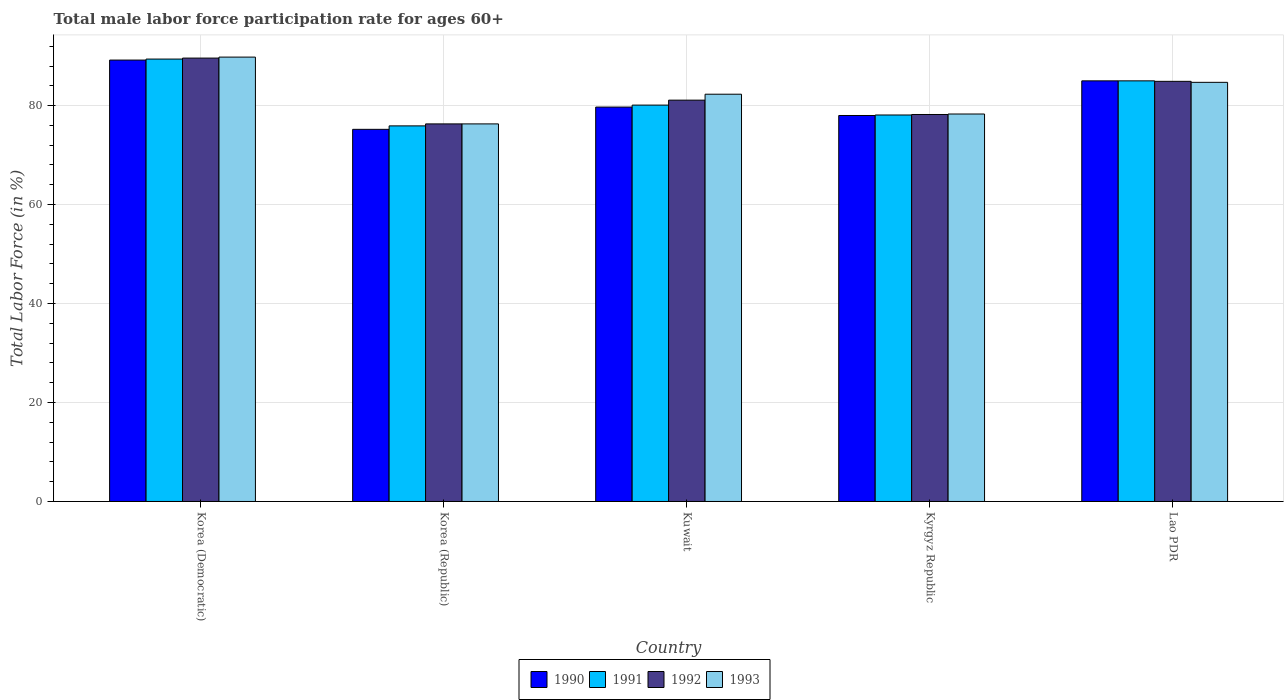How many different coloured bars are there?
Offer a very short reply. 4. How many bars are there on the 1st tick from the left?
Offer a very short reply. 4. How many bars are there on the 4th tick from the right?
Your answer should be compact. 4. What is the label of the 4th group of bars from the left?
Offer a terse response. Kyrgyz Republic. In how many cases, is the number of bars for a given country not equal to the number of legend labels?
Your answer should be compact. 0. What is the male labor force participation rate in 1992 in Lao PDR?
Keep it short and to the point. 84.9. Across all countries, what is the maximum male labor force participation rate in 1990?
Offer a terse response. 89.2. Across all countries, what is the minimum male labor force participation rate in 1992?
Offer a very short reply. 76.3. In which country was the male labor force participation rate in 1991 maximum?
Your answer should be compact. Korea (Democratic). What is the total male labor force participation rate in 1993 in the graph?
Make the answer very short. 411.4. What is the difference between the male labor force participation rate in 1991 in Kuwait and that in Lao PDR?
Your answer should be very brief. -4.9. What is the difference between the male labor force participation rate in 1993 in Korea (Democratic) and the male labor force participation rate in 1992 in Kyrgyz Republic?
Your answer should be compact. 11.6. What is the average male labor force participation rate in 1993 per country?
Provide a succinct answer. 82.28. What is the difference between the male labor force participation rate of/in 1990 and male labor force participation rate of/in 1993 in Korea (Republic)?
Provide a short and direct response. -1.1. What is the ratio of the male labor force participation rate in 1993 in Korea (Democratic) to that in Lao PDR?
Make the answer very short. 1.06. Is the male labor force participation rate in 1991 in Korea (Republic) less than that in Kuwait?
Your response must be concise. Yes. Is the difference between the male labor force participation rate in 1990 in Korea (Republic) and Kuwait greater than the difference between the male labor force participation rate in 1993 in Korea (Republic) and Kuwait?
Keep it short and to the point. Yes. What is the difference between the highest and the second highest male labor force participation rate in 1990?
Your response must be concise. 4.2. Is it the case that in every country, the sum of the male labor force participation rate in 1993 and male labor force participation rate in 1991 is greater than the sum of male labor force participation rate in 1992 and male labor force participation rate in 1990?
Your response must be concise. No. What does the 2nd bar from the left in Korea (Democratic) represents?
Keep it short and to the point. 1991. What does the 3rd bar from the right in Kuwait represents?
Provide a succinct answer. 1991. Is it the case that in every country, the sum of the male labor force participation rate in 1993 and male labor force participation rate in 1991 is greater than the male labor force participation rate in 1990?
Offer a very short reply. Yes. Are the values on the major ticks of Y-axis written in scientific E-notation?
Offer a terse response. No. Does the graph contain grids?
Provide a short and direct response. Yes. Where does the legend appear in the graph?
Provide a short and direct response. Bottom center. How many legend labels are there?
Keep it short and to the point. 4. How are the legend labels stacked?
Ensure brevity in your answer.  Horizontal. What is the title of the graph?
Your answer should be very brief. Total male labor force participation rate for ages 60+. Does "1961" appear as one of the legend labels in the graph?
Provide a succinct answer. No. What is the label or title of the Y-axis?
Your response must be concise. Total Labor Force (in %). What is the Total Labor Force (in %) of 1990 in Korea (Democratic)?
Keep it short and to the point. 89.2. What is the Total Labor Force (in %) of 1991 in Korea (Democratic)?
Your answer should be compact. 89.4. What is the Total Labor Force (in %) in 1992 in Korea (Democratic)?
Your answer should be compact. 89.6. What is the Total Labor Force (in %) of 1993 in Korea (Democratic)?
Ensure brevity in your answer.  89.8. What is the Total Labor Force (in %) of 1990 in Korea (Republic)?
Your response must be concise. 75.2. What is the Total Labor Force (in %) in 1991 in Korea (Republic)?
Make the answer very short. 75.9. What is the Total Labor Force (in %) in 1992 in Korea (Republic)?
Provide a short and direct response. 76.3. What is the Total Labor Force (in %) of 1993 in Korea (Republic)?
Your answer should be compact. 76.3. What is the Total Labor Force (in %) in 1990 in Kuwait?
Provide a short and direct response. 79.7. What is the Total Labor Force (in %) in 1991 in Kuwait?
Give a very brief answer. 80.1. What is the Total Labor Force (in %) in 1992 in Kuwait?
Offer a very short reply. 81.1. What is the Total Labor Force (in %) of 1993 in Kuwait?
Offer a very short reply. 82.3. What is the Total Labor Force (in %) of 1991 in Kyrgyz Republic?
Your answer should be compact. 78.1. What is the Total Labor Force (in %) in 1992 in Kyrgyz Republic?
Make the answer very short. 78.2. What is the Total Labor Force (in %) in 1993 in Kyrgyz Republic?
Offer a very short reply. 78.3. What is the Total Labor Force (in %) of 1992 in Lao PDR?
Your answer should be very brief. 84.9. What is the Total Labor Force (in %) of 1993 in Lao PDR?
Offer a very short reply. 84.7. Across all countries, what is the maximum Total Labor Force (in %) in 1990?
Provide a short and direct response. 89.2. Across all countries, what is the maximum Total Labor Force (in %) of 1991?
Provide a succinct answer. 89.4. Across all countries, what is the maximum Total Labor Force (in %) of 1992?
Your answer should be compact. 89.6. Across all countries, what is the maximum Total Labor Force (in %) of 1993?
Give a very brief answer. 89.8. Across all countries, what is the minimum Total Labor Force (in %) in 1990?
Your response must be concise. 75.2. Across all countries, what is the minimum Total Labor Force (in %) of 1991?
Make the answer very short. 75.9. Across all countries, what is the minimum Total Labor Force (in %) of 1992?
Make the answer very short. 76.3. Across all countries, what is the minimum Total Labor Force (in %) of 1993?
Give a very brief answer. 76.3. What is the total Total Labor Force (in %) of 1990 in the graph?
Offer a terse response. 407.1. What is the total Total Labor Force (in %) in 1991 in the graph?
Give a very brief answer. 408.5. What is the total Total Labor Force (in %) of 1992 in the graph?
Your answer should be very brief. 410.1. What is the total Total Labor Force (in %) in 1993 in the graph?
Give a very brief answer. 411.4. What is the difference between the Total Labor Force (in %) of 1990 in Korea (Democratic) and that in Korea (Republic)?
Provide a succinct answer. 14. What is the difference between the Total Labor Force (in %) of 1992 in Korea (Democratic) and that in Korea (Republic)?
Give a very brief answer. 13.3. What is the difference between the Total Labor Force (in %) of 1991 in Korea (Democratic) and that in Kuwait?
Provide a succinct answer. 9.3. What is the difference between the Total Labor Force (in %) in 1990 in Korea (Democratic) and that in Lao PDR?
Give a very brief answer. 4.2. What is the difference between the Total Labor Force (in %) in 1992 in Korea (Democratic) and that in Lao PDR?
Your response must be concise. 4.7. What is the difference between the Total Labor Force (in %) of 1993 in Korea (Democratic) and that in Lao PDR?
Provide a short and direct response. 5.1. What is the difference between the Total Labor Force (in %) of 1990 in Korea (Republic) and that in Kuwait?
Ensure brevity in your answer.  -4.5. What is the difference between the Total Labor Force (in %) of 1991 in Korea (Republic) and that in Kuwait?
Your answer should be very brief. -4.2. What is the difference between the Total Labor Force (in %) of 1992 in Korea (Republic) and that in Kuwait?
Provide a short and direct response. -4.8. What is the difference between the Total Labor Force (in %) of 1991 in Korea (Republic) and that in Kyrgyz Republic?
Offer a very short reply. -2.2. What is the difference between the Total Labor Force (in %) in 1993 in Korea (Republic) and that in Kyrgyz Republic?
Offer a terse response. -2. What is the difference between the Total Labor Force (in %) in 1992 in Korea (Republic) and that in Lao PDR?
Offer a terse response. -8.6. What is the difference between the Total Labor Force (in %) of 1990 in Kuwait and that in Kyrgyz Republic?
Provide a short and direct response. 1.7. What is the difference between the Total Labor Force (in %) in 1992 in Kuwait and that in Kyrgyz Republic?
Ensure brevity in your answer.  2.9. What is the difference between the Total Labor Force (in %) in 1990 in Kuwait and that in Lao PDR?
Your answer should be compact. -5.3. What is the difference between the Total Labor Force (in %) of 1991 in Kuwait and that in Lao PDR?
Give a very brief answer. -4.9. What is the difference between the Total Labor Force (in %) in 1992 in Kuwait and that in Lao PDR?
Provide a short and direct response. -3.8. What is the difference between the Total Labor Force (in %) of 1990 in Kyrgyz Republic and that in Lao PDR?
Offer a terse response. -7. What is the difference between the Total Labor Force (in %) of 1991 in Kyrgyz Republic and that in Lao PDR?
Your response must be concise. -6.9. What is the difference between the Total Labor Force (in %) of 1990 in Korea (Democratic) and the Total Labor Force (in %) of 1992 in Korea (Republic)?
Your response must be concise. 12.9. What is the difference between the Total Labor Force (in %) of 1990 in Korea (Democratic) and the Total Labor Force (in %) of 1993 in Korea (Republic)?
Your response must be concise. 12.9. What is the difference between the Total Labor Force (in %) of 1992 in Korea (Democratic) and the Total Labor Force (in %) of 1993 in Korea (Republic)?
Offer a very short reply. 13.3. What is the difference between the Total Labor Force (in %) in 1991 in Korea (Democratic) and the Total Labor Force (in %) in 1992 in Kuwait?
Make the answer very short. 8.3. What is the difference between the Total Labor Force (in %) of 1991 in Korea (Democratic) and the Total Labor Force (in %) of 1993 in Kuwait?
Provide a succinct answer. 7.1. What is the difference between the Total Labor Force (in %) of 1992 in Korea (Democratic) and the Total Labor Force (in %) of 1993 in Kuwait?
Your answer should be very brief. 7.3. What is the difference between the Total Labor Force (in %) of 1990 in Korea (Democratic) and the Total Labor Force (in %) of 1992 in Kyrgyz Republic?
Provide a short and direct response. 11. What is the difference between the Total Labor Force (in %) of 1990 in Korea (Democratic) and the Total Labor Force (in %) of 1993 in Kyrgyz Republic?
Provide a succinct answer. 10.9. What is the difference between the Total Labor Force (in %) of 1991 in Korea (Democratic) and the Total Labor Force (in %) of 1993 in Kyrgyz Republic?
Provide a short and direct response. 11.1. What is the difference between the Total Labor Force (in %) in 1990 in Korea (Democratic) and the Total Labor Force (in %) in 1992 in Lao PDR?
Give a very brief answer. 4.3. What is the difference between the Total Labor Force (in %) in 1990 in Korea (Democratic) and the Total Labor Force (in %) in 1993 in Lao PDR?
Your answer should be very brief. 4.5. What is the difference between the Total Labor Force (in %) in 1990 in Korea (Republic) and the Total Labor Force (in %) in 1991 in Kuwait?
Keep it short and to the point. -4.9. What is the difference between the Total Labor Force (in %) in 1990 in Korea (Republic) and the Total Labor Force (in %) in 1992 in Kuwait?
Offer a terse response. -5.9. What is the difference between the Total Labor Force (in %) of 1990 in Korea (Republic) and the Total Labor Force (in %) of 1993 in Kuwait?
Offer a terse response. -7.1. What is the difference between the Total Labor Force (in %) of 1991 in Korea (Republic) and the Total Labor Force (in %) of 1992 in Kuwait?
Your answer should be very brief. -5.2. What is the difference between the Total Labor Force (in %) in 1992 in Korea (Republic) and the Total Labor Force (in %) in 1993 in Kuwait?
Make the answer very short. -6. What is the difference between the Total Labor Force (in %) of 1990 in Korea (Republic) and the Total Labor Force (in %) of 1992 in Kyrgyz Republic?
Give a very brief answer. -3. What is the difference between the Total Labor Force (in %) in 1991 in Korea (Republic) and the Total Labor Force (in %) in 1993 in Kyrgyz Republic?
Ensure brevity in your answer.  -2.4. What is the difference between the Total Labor Force (in %) in 1992 in Korea (Republic) and the Total Labor Force (in %) in 1993 in Kyrgyz Republic?
Provide a short and direct response. -2. What is the difference between the Total Labor Force (in %) of 1990 in Korea (Republic) and the Total Labor Force (in %) of 1991 in Lao PDR?
Your answer should be very brief. -9.8. What is the difference between the Total Labor Force (in %) in 1990 in Korea (Republic) and the Total Labor Force (in %) in 1992 in Lao PDR?
Offer a very short reply. -9.7. What is the difference between the Total Labor Force (in %) in 1990 in Korea (Republic) and the Total Labor Force (in %) in 1993 in Lao PDR?
Provide a short and direct response. -9.5. What is the difference between the Total Labor Force (in %) in 1991 in Korea (Republic) and the Total Labor Force (in %) in 1993 in Lao PDR?
Your answer should be compact. -8.8. What is the difference between the Total Labor Force (in %) in 1990 in Kuwait and the Total Labor Force (in %) in 1991 in Kyrgyz Republic?
Make the answer very short. 1.6. What is the difference between the Total Labor Force (in %) of 1990 in Kuwait and the Total Labor Force (in %) of 1993 in Kyrgyz Republic?
Offer a terse response. 1.4. What is the difference between the Total Labor Force (in %) of 1991 in Kuwait and the Total Labor Force (in %) of 1992 in Kyrgyz Republic?
Your response must be concise. 1.9. What is the difference between the Total Labor Force (in %) of 1990 in Kuwait and the Total Labor Force (in %) of 1991 in Lao PDR?
Your response must be concise. -5.3. What is the difference between the Total Labor Force (in %) of 1990 in Kuwait and the Total Labor Force (in %) of 1993 in Lao PDR?
Ensure brevity in your answer.  -5. What is the difference between the Total Labor Force (in %) of 1992 in Kuwait and the Total Labor Force (in %) of 1993 in Lao PDR?
Your answer should be compact. -3.6. What is the difference between the Total Labor Force (in %) of 1990 in Kyrgyz Republic and the Total Labor Force (in %) of 1991 in Lao PDR?
Offer a terse response. -7. What is the difference between the Total Labor Force (in %) of 1990 in Kyrgyz Republic and the Total Labor Force (in %) of 1992 in Lao PDR?
Your answer should be very brief. -6.9. What is the difference between the Total Labor Force (in %) in 1991 in Kyrgyz Republic and the Total Labor Force (in %) in 1992 in Lao PDR?
Provide a succinct answer. -6.8. What is the difference between the Total Labor Force (in %) in 1991 in Kyrgyz Republic and the Total Labor Force (in %) in 1993 in Lao PDR?
Your answer should be compact. -6.6. What is the average Total Labor Force (in %) of 1990 per country?
Your answer should be very brief. 81.42. What is the average Total Labor Force (in %) of 1991 per country?
Give a very brief answer. 81.7. What is the average Total Labor Force (in %) of 1992 per country?
Offer a terse response. 82.02. What is the average Total Labor Force (in %) of 1993 per country?
Offer a terse response. 82.28. What is the difference between the Total Labor Force (in %) of 1990 and Total Labor Force (in %) of 1993 in Korea (Democratic)?
Offer a terse response. -0.6. What is the difference between the Total Labor Force (in %) in 1991 and Total Labor Force (in %) in 1993 in Korea (Democratic)?
Give a very brief answer. -0.4. What is the difference between the Total Labor Force (in %) in 1991 and Total Labor Force (in %) in 1992 in Korea (Republic)?
Ensure brevity in your answer.  -0.4. What is the difference between the Total Labor Force (in %) in 1992 and Total Labor Force (in %) in 1993 in Korea (Republic)?
Provide a short and direct response. 0. What is the difference between the Total Labor Force (in %) of 1991 and Total Labor Force (in %) of 1992 in Kuwait?
Provide a short and direct response. -1. What is the difference between the Total Labor Force (in %) in 1992 and Total Labor Force (in %) in 1993 in Kuwait?
Provide a short and direct response. -1.2. What is the difference between the Total Labor Force (in %) in 1990 and Total Labor Force (in %) in 1993 in Kyrgyz Republic?
Give a very brief answer. -0.3. What is the difference between the Total Labor Force (in %) of 1990 and Total Labor Force (in %) of 1991 in Lao PDR?
Your response must be concise. 0. What is the difference between the Total Labor Force (in %) of 1990 and Total Labor Force (in %) of 1992 in Lao PDR?
Your answer should be very brief. 0.1. What is the difference between the Total Labor Force (in %) in 1990 and Total Labor Force (in %) in 1993 in Lao PDR?
Your answer should be compact. 0.3. What is the difference between the Total Labor Force (in %) in 1991 and Total Labor Force (in %) in 1993 in Lao PDR?
Offer a very short reply. 0.3. What is the difference between the Total Labor Force (in %) of 1992 and Total Labor Force (in %) of 1993 in Lao PDR?
Offer a very short reply. 0.2. What is the ratio of the Total Labor Force (in %) of 1990 in Korea (Democratic) to that in Korea (Republic)?
Provide a short and direct response. 1.19. What is the ratio of the Total Labor Force (in %) in 1991 in Korea (Democratic) to that in Korea (Republic)?
Make the answer very short. 1.18. What is the ratio of the Total Labor Force (in %) of 1992 in Korea (Democratic) to that in Korea (Republic)?
Provide a short and direct response. 1.17. What is the ratio of the Total Labor Force (in %) in 1993 in Korea (Democratic) to that in Korea (Republic)?
Provide a short and direct response. 1.18. What is the ratio of the Total Labor Force (in %) in 1990 in Korea (Democratic) to that in Kuwait?
Offer a terse response. 1.12. What is the ratio of the Total Labor Force (in %) of 1991 in Korea (Democratic) to that in Kuwait?
Keep it short and to the point. 1.12. What is the ratio of the Total Labor Force (in %) in 1992 in Korea (Democratic) to that in Kuwait?
Keep it short and to the point. 1.1. What is the ratio of the Total Labor Force (in %) in 1993 in Korea (Democratic) to that in Kuwait?
Make the answer very short. 1.09. What is the ratio of the Total Labor Force (in %) of 1990 in Korea (Democratic) to that in Kyrgyz Republic?
Your response must be concise. 1.14. What is the ratio of the Total Labor Force (in %) of 1991 in Korea (Democratic) to that in Kyrgyz Republic?
Ensure brevity in your answer.  1.14. What is the ratio of the Total Labor Force (in %) of 1992 in Korea (Democratic) to that in Kyrgyz Republic?
Your answer should be very brief. 1.15. What is the ratio of the Total Labor Force (in %) in 1993 in Korea (Democratic) to that in Kyrgyz Republic?
Provide a succinct answer. 1.15. What is the ratio of the Total Labor Force (in %) of 1990 in Korea (Democratic) to that in Lao PDR?
Your answer should be very brief. 1.05. What is the ratio of the Total Labor Force (in %) in 1991 in Korea (Democratic) to that in Lao PDR?
Your answer should be compact. 1.05. What is the ratio of the Total Labor Force (in %) in 1992 in Korea (Democratic) to that in Lao PDR?
Make the answer very short. 1.06. What is the ratio of the Total Labor Force (in %) in 1993 in Korea (Democratic) to that in Lao PDR?
Give a very brief answer. 1.06. What is the ratio of the Total Labor Force (in %) in 1990 in Korea (Republic) to that in Kuwait?
Keep it short and to the point. 0.94. What is the ratio of the Total Labor Force (in %) of 1991 in Korea (Republic) to that in Kuwait?
Give a very brief answer. 0.95. What is the ratio of the Total Labor Force (in %) in 1992 in Korea (Republic) to that in Kuwait?
Your response must be concise. 0.94. What is the ratio of the Total Labor Force (in %) in 1993 in Korea (Republic) to that in Kuwait?
Offer a terse response. 0.93. What is the ratio of the Total Labor Force (in %) of 1990 in Korea (Republic) to that in Kyrgyz Republic?
Offer a terse response. 0.96. What is the ratio of the Total Labor Force (in %) in 1991 in Korea (Republic) to that in Kyrgyz Republic?
Your answer should be very brief. 0.97. What is the ratio of the Total Labor Force (in %) of 1992 in Korea (Republic) to that in Kyrgyz Republic?
Provide a short and direct response. 0.98. What is the ratio of the Total Labor Force (in %) of 1993 in Korea (Republic) to that in Kyrgyz Republic?
Keep it short and to the point. 0.97. What is the ratio of the Total Labor Force (in %) of 1990 in Korea (Republic) to that in Lao PDR?
Offer a very short reply. 0.88. What is the ratio of the Total Labor Force (in %) in 1991 in Korea (Republic) to that in Lao PDR?
Ensure brevity in your answer.  0.89. What is the ratio of the Total Labor Force (in %) of 1992 in Korea (Republic) to that in Lao PDR?
Keep it short and to the point. 0.9. What is the ratio of the Total Labor Force (in %) of 1993 in Korea (Republic) to that in Lao PDR?
Make the answer very short. 0.9. What is the ratio of the Total Labor Force (in %) in 1990 in Kuwait to that in Kyrgyz Republic?
Provide a succinct answer. 1.02. What is the ratio of the Total Labor Force (in %) of 1991 in Kuwait to that in Kyrgyz Republic?
Your answer should be compact. 1.03. What is the ratio of the Total Labor Force (in %) of 1992 in Kuwait to that in Kyrgyz Republic?
Your answer should be very brief. 1.04. What is the ratio of the Total Labor Force (in %) in 1993 in Kuwait to that in Kyrgyz Republic?
Keep it short and to the point. 1.05. What is the ratio of the Total Labor Force (in %) in 1990 in Kuwait to that in Lao PDR?
Ensure brevity in your answer.  0.94. What is the ratio of the Total Labor Force (in %) in 1991 in Kuwait to that in Lao PDR?
Offer a terse response. 0.94. What is the ratio of the Total Labor Force (in %) of 1992 in Kuwait to that in Lao PDR?
Your response must be concise. 0.96. What is the ratio of the Total Labor Force (in %) in 1993 in Kuwait to that in Lao PDR?
Provide a succinct answer. 0.97. What is the ratio of the Total Labor Force (in %) of 1990 in Kyrgyz Republic to that in Lao PDR?
Offer a terse response. 0.92. What is the ratio of the Total Labor Force (in %) in 1991 in Kyrgyz Republic to that in Lao PDR?
Make the answer very short. 0.92. What is the ratio of the Total Labor Force (in %) in 1992 in Kyrgyz Republic to that in Lao PDR?
Your answer should be very brief. 0.92. What is the ratio of the Total Labor Force (in %) of 1993 in Kyrgyz Republic to that in Lao PDR?
Provide a short and direct response. 0.92. What is the difference between the highest and the second highest Total Labor Force (in %) in 1992?
Keep it short and to the point. 4.7. What is the difference between the highest and the second highest Total Labor Force (in %) in 1993?
Your response must be concise. 5.1. What is the difference between the highest and the lowest Total Labor Force (in %) in 1992?
Provide a short and direct response. 13.3. 